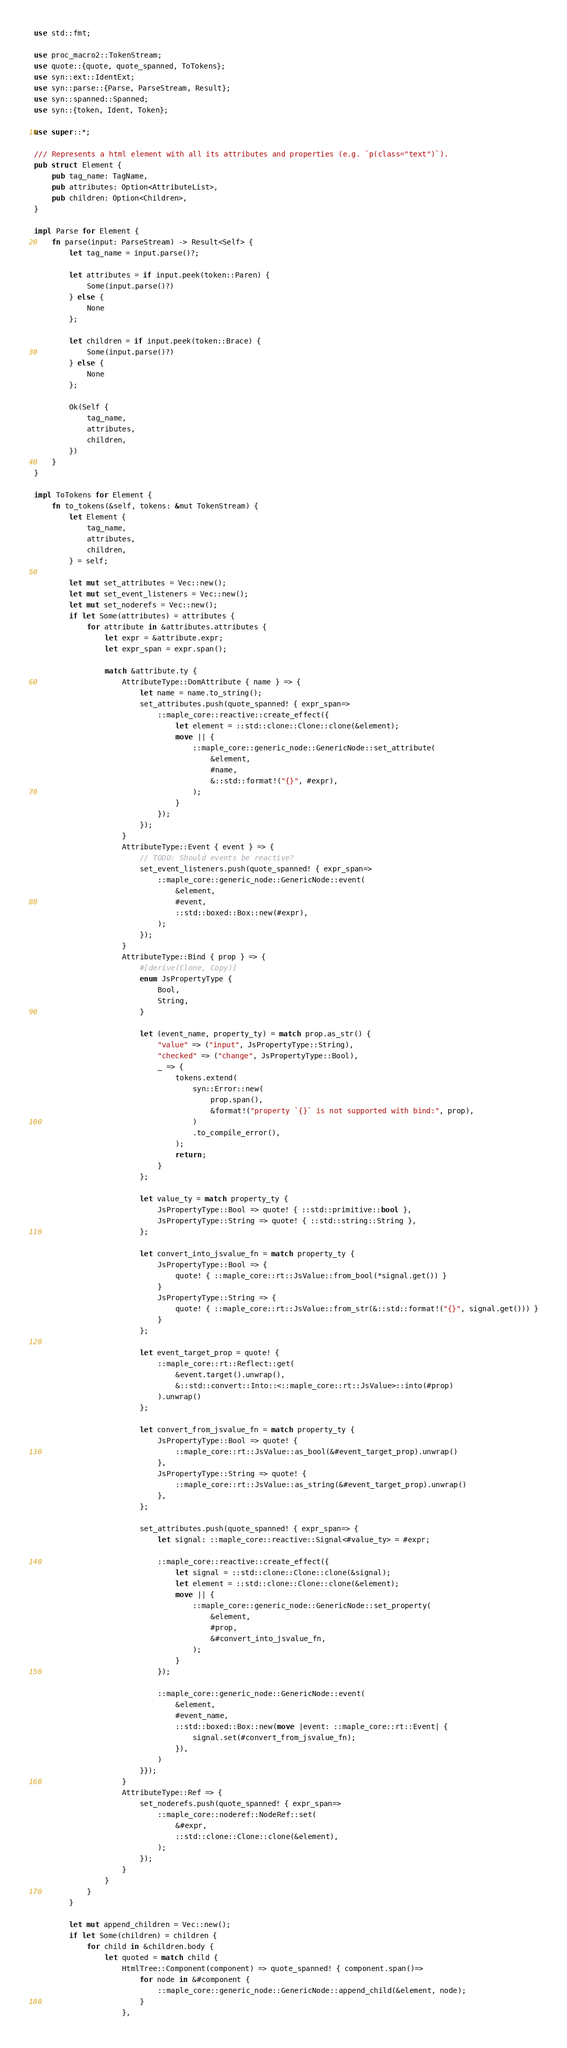Convert code to text. <code><loc_0><loc_0><loc_500><loc_500><_Rust_>use std::fmt;

use proc_macro2::TokenStream;
use quote::{quote, quote_spanned, ToTokens};
use syn::ext::IdentExt;
use syn::parse::{Parse, ParseStream, Result};
use syn::spanned::Spanned;
use syn::{token, Ident, Token};

use super::*;

/// Represents a html element with all its attributes and properties (e.g. `p(class="text")`).
pub struct Element {
    pub tag_name: TagName,
    pub attributes: Option<AttributeList>,
    pub children: Option<Children>,
}

impl Parse for Element {
    fn parse(input: ParseStream) -> Result<Self> {
        let tag_name = input.parse()?;

        let attributes = if input.peek(token::Paren) {
            Some(input.parse()?)
        } else {
            None
        };

        let children = if input.peek(token::Brace) {
            Some(input.parse()?)
        } else {
            None
        };

        Ok(Self {
            tag_name,
            attributes,
            children,
        })
    }
}

impl ToTokens for Element {
    fn to_tokens(&self, tokens: &mut TokenStream) {
        let Element {
            tag_name,
            attributes,
            children,
        } = self;

        let mut set_attributes = Vec::new();
        let mut set_event_listeners = Vec::new();
        let mut set_noderefs = Vec::new();
        if let Some(attributes) = attributes {
            for attribute in &attributes.attributes {
                let expr = &attribute.expr;
                let expr_span = expr.span();

                match &attribute.ty {
                    AttributeType::DomAttribute { name } => {
                        let name = name.to_string();
                        set_attributes.push(quote_spanned! { expr_span=>
                            ::maple_core::reactive::create_effect({
                                let element = ::std::clone::Clone::clone(&element);
                                move || {
                                    ::maple_core::generic_node::GenericNode::set_attribute(
                                        &element,
                                        #name,
                                        &::std::format!("{}", #expr),
                                    );
                                }
                            });
                        });
                    }
                    AttributeType::Event { event } => {
                        // TODO: Should events be reactive?
                        set_event_listeners.push(quote_spanned! { expr_span=>
                            ::maple_core::generic_node::GenericNode::event(
                                &element,
                                #event,
                                ::std::boxed::Box::new(#expr),
                            );
                        });
                    }
                    AttributeType::Bind { prop } => {
                        #[derive(Clone, Copy)]
                        enum JsPropertyType {
                            Bool,
                            String,
                        }

                        let (event_name, property_ty) = match prop.as_str() {
                            "value" => ("input", JsPropertyType::String),
                            "checked" => ("change", JsPropertyType::Bool),
                            _ => {
                                tokens.extend(
                                    syn::Error::new(
                                        prop.span(),
                                        &format!("property `{}` is not supported with bind:", prop),
                                    )
                                    .to_compile_error(),
                                );
                                return;
                            }
                        };

                        let value_ty = match property_ty {
                            JsPropertyType::Bool => quote! { ::std::primitive::bool },
                            JsPropertyType::String => quote! { ::std::string::String },
                        };

                        let convert_into_jsvalue_fn = match property_ty {
                            JsPropertyType::Bool => {
                                quote! { ::maple_core::rt::JsValue::from_bool(*signal.get()) }
                            }
                            JsPropertyType::String => {
                                quote! { ::maple_core::rt::JsValue::from_str(&::std::format!("{}", signal.get())) }
                            }
                        };

                        let event_target_prop = quote! {
                            ::maple_core::rt::Reflect::get(
                                &event.target().unwrap(),
                                &::std::convert::Into::<::maple_core::rt::JsValue>::into(#prop)
                            ).unwrap()
                        };

                        let convert_from_jsvalue_fn = match property_ty {
                            JsPropertyType::Bool => quote! {
                                ::maple_core::rt::JsValue::as_bool(&#event_target_prop).unwrap()
                            },
                            JsPropertyType::String => quote! {
                                ::maple_core::rt::JsValue::as_string(&#event_target_prop).unwrap()
                            },
                        };

                        set_attributes.push(quote_spanned! { expr_span=> {
                            let signal: ::maple_core::reactive::Signal<#value_ty> = #expr;

                            ::maple_core::reactive::create_effect({
                                let signal = ::std::clone::Clone::clone(&signal);
                                let element = ::std::clone::Clone::clone(&element);
                                move || {
                                    ::maple_core::generic_node::GenericNode::set_property(
                                        &element,
                                        #prop,
                                        &#convert_into_jsvalue_fn,
                                    );
                                }
                            });

                            ::maple_core::generic_node::GenericNode::event(
                                &element,
                                #event_name,
                                ::std::boxed::Box::new(move |event: ::maple_core::rt::Event| {
                                    signal.set(#convert_from_jsvalue_fn);
                                }),
                            )
                        }});
                    }
                    AttributeType::Ref => {
                        set_noderefs.push(quote_spanned! { expr_span=>
                            ::maple_core::noderef::NodeRef::set(
                                &#expr,
                                ::std::clone::Clone::clone(&element),
                            );
                        });
                    }
                }
            }
        }

        let mut append_children = Vec::new();
        if let Some(children) = children {
            for child in &children.body {
                let quoted = match child {
                    HtmlTree::Component(component) => quote_spanned! { component.span()=>
                        for node in &#component {
                            ::maple_core::generic_node::GenericNode::append_child(&element, node);
                        }
                    },</code> 